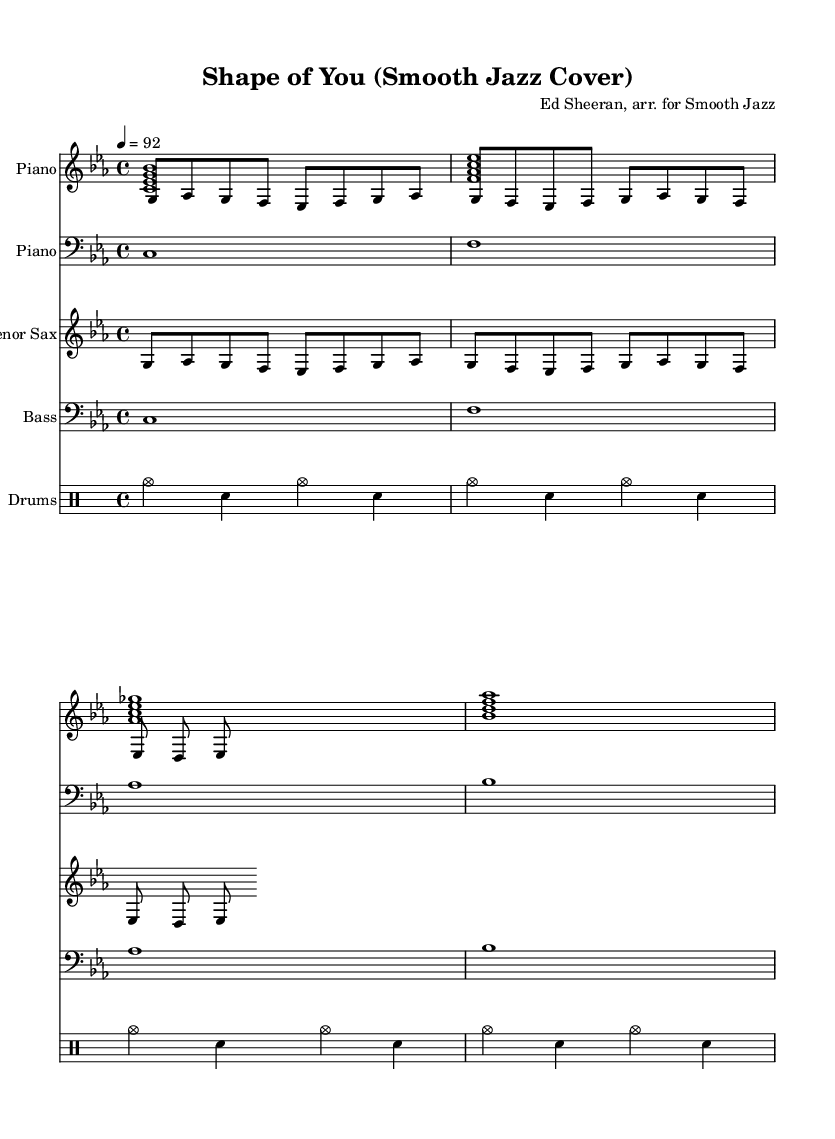what is the key signature of this music? The key signature is C minor, which has three flats: B flat, E flat, and A flat. This is identified by the presence of the flat symbols at the beginning of the staff.
Answer: C minor what is the time signature of this music? The time signature is 4/4, which means there are four beats per measure and the quarter note gets one beat. This can be seen right after the key signature at the beginning of the score.
Answer: 4/4 what is the tempo marking for this piece? The tempo marking indicates a speed of 92 beats per minute, shown at the start of the music notation. This suggests a moderate pace suitable for relaxation.
Answer: 92 how many staves are there for the piano? There are two staves for the piano: one for the right hand (RH) and one for the left hand (LH). This is indicated by having two separate piano parts labeled in the score.
Answer: Two what is the primary instrument featured in this arrangement? The primary instrument featured is the tenor saxophone, which is common in smooth jazz. This is noted by the specific staff labeled "Tenor Sax" in the score.
Answer: Tenor Sax which style of music does this arrangement belong to? This arrangement belongs to smooth jazz, indicated by the relaxed and laid-back style typically associated with smooth jazz covers of popular songs. The arrangement adapts a popular pop song into a smooth jazz format.
Answer: Smooth Jazz 